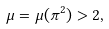Convert formula to latex. <formula><loc_0><loc_0><loc_500><loc_500>\mu = \mu ( \pi ^ { 2 } ) > 2 ,</formula> 